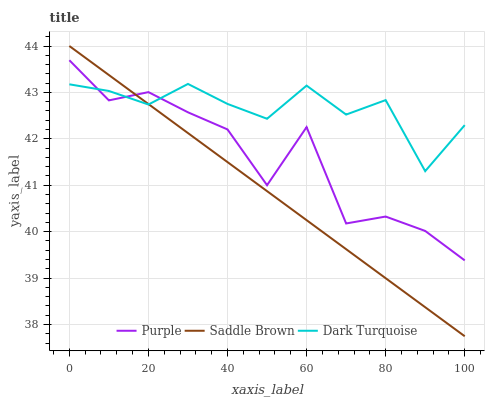Does Saddle Brown have the minimum area under the curve?
Answer yes or no. Yes. Does Dark Turquoise have the maximum area under the curve?
Answer yes or no. Yes. Does Dark Turquoise have the minimum area under the curve?
Answer yes or no. No. Does Saddle Brown have the maximum area under the curve?
Answer yes or no. No. Is Saddle Brown the smoothest?
Answer yes or no. Yes. Is Purple the roughest?
Answer yes or no. Yes. Is Dark Turquoise the smoothest?
Answer yes or no. No. Is Dark Turquoise the roughest?
Answer yes or no. No. Does Dark Turquoise have the lowest value?
Answer yes or no. No. Does Dark Turquoise have the highest value?
Answer yes or no. No. 